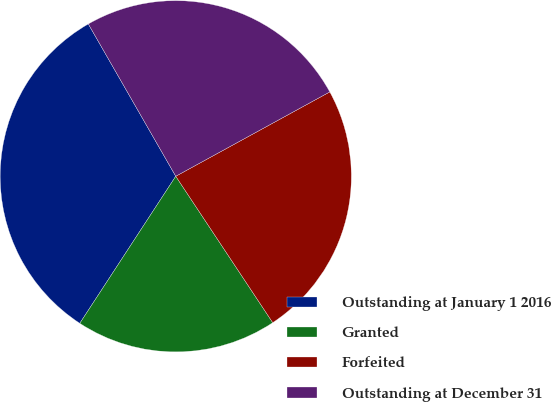Convert chart to OTSL. <chart><loc_0><loc_0><loc_500><loc_500><pie_chart><fcel>Outstanding at January 1 2016<fcel>Granted<fcel>Forfeited<fcel>Outstanding at December 31<nl><fcel>32.5%<fcel>18.51%<fcel>23.66%<fcel>25.32%<nl></chart> 